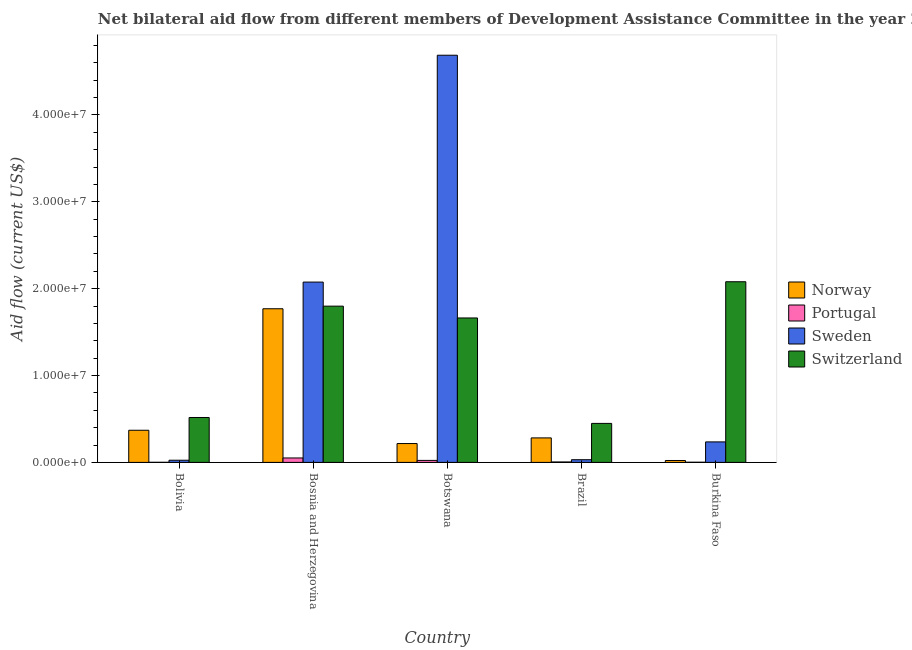Are the number of bars per tick equal to the number of legend labels?
Offer a terse response. Yes. How many bars are there on the 1st tick from the right?
Ensure brevity in your answer.  4. In how many cases, is the number of bars for a given country not equal to the number of legend labels?
Ensure brevity in your answer.  0. What is the amount of aid given by norway in Bolivia?
Your answer should be very brief. 3.70e+06. Across all countries, what is the maximum amount of aid given by norway?
Your answer should be compact. 1.77e+07. Across all countries, what is the minimum amount of aid given by portugal?
Provide a short and direct response. 10000. In which country was the amount of aid given by switzerland maximum?
Make the answer very short. Burkina Faso. What is the total amount of aid given by switzerland in the graph?
Offer a terse response. 6.51e+07. What is the difference between the amount of aid given by norway in Brazil and that in Burkina Faso?
Give a very brief answer. 2.60e+06. What is the difference between the amount of aid given by norway in Bolivia and the amount of aid given by portugal in Brazil?
Your response must be concise. 3.65e+06. What is the average amount of aid given by norway per country?
Your response must be concise. 5.32e+06. What is the difference between the amount of aid given by sweden and amount of aid given by portugal in Bolivia?
Your answer should be very brief. 2.40e+05. What is the ratio of the amount of aid given by switzerland in Bosnia and Herzegovina to that in Burkina Faso?
Your answer should be compact. 0.86. Is the amount of aid given by norway in Brazil less than that in Burkina Faso?
Ensure brevity in your answer.  No. What is the difference between the highest and the second highest amount of aid given by sweden?
Provide a succinct answer. 2.61e+07. What is the difference between the highest and the lowest amount of aid given by norway?
Provide a short and direct response. 1.75e+07. In how many countries, is the amount of aid given by sweden greater than the average amount of aid given by sweden taken over all countries?
Provide a succinct answer. 2. Is it the case that in every country, the sum of the amount of aid given by portugal and amount of aid given by sweden is greater than the sum of amount of aid given by switzerland and amount of aid given by norway?
Provide a succinct answer. No. What does the 3rd bar from the left in Bolivia represents?
Your answer should be compact. Sweden. What does the 1st bar from the right in Botswana represents?
Offer a very short reply. Switzerland. How many countries are there in the graph?
Your response must be concise. 5. Are the values on the major ticks of Y-axis written in scientific E-notation?
Offer a very short reply. Yes. Does the graph contain grids?
Make the answer very short. No. Where does the legend appear in the graph?
Give a very brief answer. Center right. How many legend labels are there?
Provide a succinct answer. 4. How are the legend labels stacked?
Your answer should be very brief. Vertical. What is the title of the graph?
Give a very brief answer. Net bilateral aid flow from different members of Development Assistance Committee in the year 2005. Does "CO2 damage" appear as one of the legend labels in the graph?
Offer a terse response. No. What is the label or title of the X-axis?
Provide a short and direct response. Country. What is the Aid flow (current US$) of Norway in Bolivia?
Make the answer very short. 3.70e+06. What is the Aid flow (current US$) of Sweden in Bolivia?
Ensure brevity in your answer.  2.50e+05. What is the Aid flow (current US$) in Switzerland in Bolivia?
Your answer should be compact. 5.17e+06. What is the Aid flow (current US$) of Norway in Bosnia and Herzegovina?
Make the answer very short. 1.77e+07. What is the Aid flow (current US$) of Portugal in Bosnia and Herzegovina?
Offer a very short reply. 5.10e+05. What is the Aid flow (current US$) in Sweden in Bosnia and Herzegovina?
Your answer should be very brief. 2.08e+07. What is the Aid flow (current US$) in Switzerland in Bosnia and Herzegovina?
Your answer should be very brief. 1.80e+07. What is the Aid flow (current US$) of Norway in Botswana?
Your answer should be compact. 2.17e+06. What is the Aid flow (current US$) of Sweden in Botswana?
Your answer should be compact. 4.69e+07. What is the Aid flow (current US$) of Switzerland in Botswana?
Keep it short and to the point. 1.66e+07. What is the Aid flow (current US$) in Norway in Brazil?
Ensure brevity in your answer.  2.82e+06. What is the Aid flow (current US$) in Portugal in Brazil?
Offer a terse response. 5.00e+04. What is the Aid flow (current US$) of Switzerland in Brazil?
Offer a very short reply. 4.49e+06. What is the Aid flow (current US$) in Sweden in Burkina Faso?
Your answer should be very brief. 2.36e+06. What is the Aid flow (current US$) in Switzerland in Burkina Faso?
Your answer should be very brief. 2.08e+07. Across all countries, what is the maximum Aid flow (current US$) of Norway?
Your answer should be compact. 1.77e+07. Across all countries, what is the maximum Aid flow (current US$) of Portugal?
Provide a short and direct response. 5.10e+05. Across all countries, what is the maximum Aid flow (current US$) in Sweden?
Your answer should be compact. 4.69e+07. Across all countries, what is the maximum Aid flow (current US$) in Switzerland?
Offer a terse response. 2.08e+07. Across all countries, what is the minimum Aid flow (current US$) in Switzerland?
Provide a succinct answer. 4.49e+06. What is the total Aid flow (current US$) of Norway in the graph?
Make the answer very short. 2.66e+07. What is the total Aid flow (current US$) of Portugal in the graph?
Offer a very short reply. 8.20e+05. What is the total Aid flow (current US$) in Sweden in the graph?
Ensure brevity in your answer.  7.06e+07. What is the total Aid flow (current US$) of Switzerland in the graph?
Offer a very short reply. 6.51e+07. What is the difference between the Aid flow (current US$) in Norway in Bolivia and that in Bosnia and Herzegovina?
Your answer should be compact. -1.40e+07. What is the difference between the Aid flow (current US$) of Portugal in Bolivia and that in Bosnia and Herzegovina?
Offer a terse response. -5.00e+05. What is the difference between the Aid flow (current US$) in Sweden in Bolivia and that in Bosnia and Herzegovina?
Give a very brief answer. -2.05e+07. What is the difference between the Aid flow (current US$) in Switzerland in Bolivia and that in Bosnia and Herzegovina?
Offer a very short reply. -1.28e+07. What is the difference between the Aid flow (current US$) of Norway in Bolivia and that in Botswana?
Your answer should be compact. 1.53e+06. What is the difference between the Aid flow (current US$) in Portugal in Bolivia and that in Botswana?
Make the answer very short. -2.20e+05. What is the difference between the Aid flow (current US$) of Sweden in Bolivia and that in Botswana?
Offer a very short reply. -4.66e+07. What is the difference between the Aid flow (current US$) in Switzerland in Bolivia and that in Botswana?
Provide a short and direct response. -1.15e+07. What is the difference between the Aid flow (current US$) of Norway in Bolivia and that in Brazil?
Offer a terse response. 8.80e+05. What is the difference between the Aid flow (current US$) in Portugal in Bolivia and that in Brazil?
Your answer should be very brief. -4.00e+04. What is the difference between the Aid flow (current US$) in Sweden in Bolivia and that in Brazil?
Your answer should be compact. -6.00e+04. What is the difference between the Aid flow (current US$) in Switzerland in Bolivia and that in Brazil?
Your answer should be very brief. 6.80e+05. What is the difference between the Aid flow (current US$) of Norway in Bolivia and that in Burkina Faso?
Offer a terse response. 3.48e+06. What is the difference between the Aid flow (current US$) of Portugal in Bolivia and that in Burkina Faso?
Your answer should be very brief. -10000. What is the difference between the Aid flow (current US$) of Sweden in Bolivia and that in Burkina Faso?
Give a very brief answer. -2.11e+06. What is the difference between the Aid flow (current US$) of Switzerland in Bolivia and that in Burkina Faso?
Your response must be concise. -1.56e+07. What is the difference between the Aid flow (current US$) of Norway in Bosnia and Herzegovina and that in Botswana?
Your answer should be compact. 1.55e+07. What is the difference between the Aid flow (current US$) in Portugal in Bosnia and Herzegovina and that in Botswana?
Provide a short and direct response. 2.80e+05. What is the difference between the Aid flow (current US$) in Sweden in Bosnia and Herzegovina and that in Botswana?
Your answer should be compact. -2.61e+07. What is the difference between the Aid flow (current US$) of Switzerland in Bosnia and Herzegovina and that in Botswana?
Keep it short and to the point. 1.36e+06. What is the difference between the Aid flow (current US$) of Norway in Bosnia and Herzegovina and that in Brazil?
Keep it short and to the point. 1.49e+07. What is the difference between the Aid flow (current US$) in Portugal in Bosnia and Herzegovina and that in Brazil?
Give a very brief answer. 4.60e+05. What is the difference between the Aid flow (current US$) in Sweden in Bosnia and Herzegovina and that in Brazil?
Keep it short and to the point. 2.04e+07. What is the difference between the Aid flow (current US$) of Switzerland in Bosnia and Herzegovina and that in Brazil?
Offer a terse response. 1.35e+07. What is the difference between the Aid flow (current US$) of Norway in Bosnia and Herzegovina and that in Burkina Faso?
Your response must be concise. 1.75e+07. What is the difference between the Aid flow (current US$) in Portugal in Bosnia and Herzegovina and that in Burkina Faso?
Offer a very short reply. 4.90e+05. What is the difference between the Aid flow (current US$) of Sweden in Bosnia and Herzegovina and that in Burkina Faso?
Your response must be concise. 1.84e+07. What is the difference between the Aid flow (current US$) of Switzerland in Bosnia and Herzegovina and that in Burkina Faso?
Give a very brief answer. -2.81e+06. What is the difference between the Aid flow (current US$) in Norway in Botswana and that in Brazil?
Ensure brevity in your answer.  -6.50e+05. What is the difference between the Aid flow (current US$) of Sweden in Botswana and that in Brazil?
Your response must be concise. 4.66e+07. What is the difference between the Aid flow (current US$) in Switzerland in Botswana and that in Brazil?
Give a very brief answer. 1.21e+07. What is the difference between the Aid flow (current US$) of Norway in Botswana and that in Burkina Faso?
Ensure brevity in your answer.  1.95e+06. What is the difference between the Aid flow (current US$) in Sweden in Botswana and that in Burkina Faso?
Make the answer very short. 4.45e+07. What is the difference between the Aid flow (current US$) of Switzerland in Botswana and that in Burkina Faso?
Offer a terse response. -4.17e+06. What is the difference between the Aid flow (current US$) of Norway in Brazil and that in Burkina Faso?
Provide a succinct answer. 2.60e+06. What is the difference between the Aid flow (current US$) of Portugal in Brazil and that in Burkina Faso?
Keep it short and to the point. 3.00e+04. What is the difference between the Aid flow (current US$) in Sweden in Brazil and that in Burkina Faso?
Give a very brief answer. -2.05e+06. What is the difference between the Aid flow (current US$) of Switzerland in Brazil and that in Burkina Faso?
Your response must be concise. -1.63e+07. What is the difference between the Aid flow (current US$) in Norway in Bolivia and the Aid flow (current US$) in Portugal in Bosnia and Herzegovina?
Provide a short and direct response. 3.19e+06. What is the difference between the Aid flow (current US$) of Norway in Bolivia and the Aid flow (current US$) of Sweden in Bosnia and Herzegovina?
Give a very brief answer. -1.71e+07. What is the difference between the Aid flow (current US$) in Norway in Bolivia and the Aid flow (current US$) in Switzerland in Bosnia and Herzegovina?
Your response must be concise. -1.43e+07. What is the difference between the Aid flow (current US$) in Portugal in Bolivia and the Aid flow (current US$) in Sweden in Bosnia and Herzegovina?
Make the answer very short. -2.08e+07. What is the difference between the Aid flow (current US$) of Portugal in Bolivia and the Aid flow (current US$) of Switzerland in Bosnia and Herzegovina?
Offer a terse response. -1.80e+07. What is the difference between the Aid flow (current US$) in Sweden in Bolivia and the Aid flow (current US$) in Switzerland in Bosnia and Herzegovina?
Offer a very short reply. -1.77e+07. What is the difference between the Aid flow (current US$) of Norway in Bolivia and the Aid flow (current US$) of Portugal in Botswana?
Make the answer very short. 3.47e+06. What is the difference between the Aid flow (current US$) in Norway in Bolivia and the Aid flow (current US$) in Sweden in Botswana?
Your response must be concise. -4.32e+07. What is the difference between the Aid flow (current US$) of Norway in Bolivia and the Aid flow (current US$) of Switzerland in Botswana?
Ensure brevity in your answer.  -1.29e+07. What is the difference between the Aid flow (current US$) in Portugal in Bolivia and the Aid flow (current US$) in Sweden in Botswana?
Give a very brief answer. -4.69e+07. What is the difference between the Aid flow (current US$) in Portugal in Bolivia and the Aid flow (current US$) in Switzerland in Botswana?
Offer a terse response. -1.66e+07. What is the difference between the Aid flow (current US$) of Sweden in Bolivia and the Aid flow (current US$) of Switzerland in Botswana?
Provide a short and direct response. -1.64e+07. What is the difference between the Aid flow (current US$) in Norway in Bolivia and the Aid flow (current US$) in Portugal in Brazil?
Offer a terse response. 3.65e+06. What is the difference between the Aid flow (current US$) in Norway in Bolivia and the Aid flow (current US$) in Sweden in Brazil?
Provide a short and direct response. 3.39e+06. What is the difference between the Aid flow (current US$) in Norway in Bolivia and the Aid flow (current US$) in Switzerland in Brazil?
Provide a short and direct response. -7.90e+05. What is the difference between the Aid flow (current US$) of Portugal in Bolivia and the Aid flow (current US$) of Sweden in Brazil?
Offer a terse response. -3.00e+05. What is the difference between the Aid flow (current US$) in Portugal in Bolivia and the Aid flow (current US$) in Switzerland in Brazil?
Give a very brief answer. -4.48e+06. What is the difference between the Aid flow (current US$) of Sweden in Bolivia and the Aid flow (current US$) of Switzerland in Brazil?
Ensure brevity in your answer.  -4.24e+06. What is the difference between the Aid flow (current US$) of Norway in Bolivia and the Aid flow (current US$) of Portugal in Burkina Faso?
Ensure brevity in your answer.  3.68e+06. What is the difference between the Aid flow (current US$) of Norway in Bolivia and the Aid flow (current US$) of Sweden in Burkina Faso?
Ensure brevity in your answer.  1.34e+06. What is the difference between the Aid flow (current US$) of Norway in Bolivia and the Aid flow (current US$) of Switzerland in Burkina Faso?
Offer a terse response. -1.71e+07. What is the difference between the Aid flow (current US$) in Portugal in Bolivia and the Aid flow (current US$) in Sweden in Burkina Faso?
Provide a succinct answer. -2.35e+06. What is the difference between the Aid flow (current US$) in Portugal in Bolivia and the Aid flow (current US$) in Switzerland in Burkina Faso?
Provide a short and direct response. -2.08e+07. What is the difference between the Aid flow (current US$) of Sweden in Bolivia and the Aid flow (current US$) of Switzerland in Burkina Faso?
Offer a very short reply. -2.06e+07. What is the difference between the Aid flow (current US$) in Norway in Bosnia and Herzegovina and the Aid flow (current US$) in Portugal in Botswana?
Offer a terse response. 1.75e+07. What is the difference between the Aid flow (current US$) in Norway in Bosnia and Herzegovina and the Aid flow (current US$) in Sweden in Botswana?
Offer a terse response. -2.92e+07. What is the difference between the Aid flow (current US$) of Norway in Bosnia and Herzegovina and the Aid flow (current US$) of Switzerland in Botswana?
Your answer should be compact. 1.06e+06. What is the difference between the Aid flow (current US$) of Portugal in Bosnia and Herzegovina and the Aid flow (current US$) of Sweden in Botswana?
Ensure brevity in your answer.  -4.64e+07. What is the difference between the Aid flow (current US$) in Portugal in Bosnia and Herzegovina and the Aid flow (current US$) in Switzerland in Botswana?
Give a very brief answer. -1.61e+07. What is the difference between the Aid flow (current US$) in Sweden in Bosnia and Herzegovina and the Aid flow (current US$) in Switzerland in Botswana?
Provide a short and direct response. 4.13e+06. What is the difference between the Aid flow (current US$) in Norway in Bosnia and Herzegovina and the Aid flow (current US$) in Portugal in Brazil?
Offer a terse response. 1.76e+07. What is the difference between the Aid flow (current US$) in Norway in Bosnia and Herzegovina and the Aid flow (current US$) in Sweden in Brazil?
Your answer should be very brief. 1.74e+07. What is the difference between the Aid flow (current US$) in Norway in Bosnia and Herzegovina and the Aid flow (current US$) in Switzerland in Brazil?
Offer a very short reply. 1.32e+07. What is the difference between the Aid flow (current US$) in Portugal in Bosnia and Herzegovina and the Aid flow (current US$) in Switzerland in Brazil?
Provide a short and direct response. -3.98e+06. What is the difference between the Aid flow (current US$) of Sweden in Bosnia and Herzegovina and the Aid flow (current US$) of Switzerland in Brazil?
Your response must be concise. 1.63e+07. What is the difference between the Aid flow (current US$) in Norway in Bosnia and Herzegovina and the Aid flow (current US$) in Portugal in Burkina Faso?
Offer a very short reply. 1.77e+07. What is the difference between the Aid flow (current US$) of Norway in Bosnia and Herzegovina and the Aid flow (current US$) of Sweden in Burkina Faso?
Offer a very short reply. 1.53e+07. What is the difference between the Aid flow (current US$) of Norway in Bosnia and Herzegovina and the Aid flow (current US$) of Switzerland in Burkina Faso?
Ensure brevity in your answer.  -3.11e+06. What is the difference between the Aid flow (current US$) in Portugal in Bosnia and Herzegovina and the Aid flow (current US$) in Sweden in Burkina Faso?
Keep it short and to the point. -1.85e+06. What is the difference between the Aid flow (current US$) of Portugal in Bosnia and Herzegovina and the Aid flow (current US$) of Switzerland in Burkina Faso?
Offer a terse response. -2.03e+07. What is the difference between the Aid flow (current US$) in Sweden in Bosnia and Herzegovina and the Aid flow (current US$) in Switzerland in Burkina Faso?
Your answer should be very brief. -4.00e+04. What is the difference between the Aid flow (current US$) of Norway in Botswana and the Aid flow (current US$) of Portugal in Brazil?
Ensure brevity in your answer.  2.12e+06. What is the difference between the Aid flow (current US$) of Norway in Botswana and the Aid flow (current US$) of Sweden in Brazil?
Provide a short and direct response. 1.86e+06. What is the difference between the Aid flow (current US$) of Norway in Botswana and the Aid flow (current US$) of Switzerland in Brazil?
Offer a terse response. -2.32e+06. What is the difference between the Aid flow (current US$) of Portugal in Botswana and the Aid flow (current US$) of Sweden in Brazil?
Your answer should be very brief. -8.00e+04. What is the difference between the Aid flow (current US$) in Portugal in Botswana and the Aid flow (current US$) in Switzerland in Brazil?
Ensure brevity in your answer.  -4.26e+06. What is the difference between the Aid flow (current US$) of Sweden in Botswana and the Aid flow (current US$) of Switzerland in Brazil?
Offer a very short reply. 4.24e+07. What is the difference between the Aid flow (current US$) in Norway in Botswana and the Aid flow (current US$) in Portugal in Burkina Faso?
Your answer should be compact. 2.15e+06. What is the difference between the Aid flow (current US$) in Norway in Botswana and the Aid flow (current US$) in Sweden in Burkina Faso?
Your answer should be very brief. -1.90e+05. What is the difference between the Aid flow (current US$) of Norway in Botswana and the Aid flow (current US$) of Switzerland in Burkina Faso?
Make the answer very short. -1.86e+07. What is the difference between the Aid flow (current US$) of Portugal in Botswana and the Aid flow (current US$) of Sweden in Burkina Faso?
Make the answer very short. -2.13e+06. What is the difference between the Aid flow (current US$) in Portugal in Botswana and the Aid flow (current US$) in Switzerland in Burkina Faso?
Offer a terse response. -2.06e+07. What is the difference between the Aid flow (current US$) in Sweden in Botswana and the Aid flow (current US$) in Switzerland in Burkina Faso?
Keep it short and to the point. 2.61e+07. What is the difference between the Aid flow (current US$) of Norway in Brazil and the Aid flow (current US$) of Portugal in Burkina Faso?
Your answer should be very brief. 2.80e+06. What is the difference between the Aid flow (current US$) in Norway in Brazil and the Aid flow (current US$) in Sweden in Burkina Faso?
Your response must be concise. 4.60e+05. What is the difference between the Aid flow (current US$) of Norway in Brazil and the Aid flow (current US$) of Switzerland in Burkina Faso?
Offer a very short reply. -1.80e+07. What is the difference between the Aid flow (current US$) of Portugal in Brazil and the Aid flow (current US$) of Sweden in Burkina Faso?
Keep it short and to the point. -2.31e+06. What is the difference between the Aid flow (current US$) in Portugal in Brazil and the Aid flow (current US$) in Switzerland in Burkina Faso?
Your response must be concise. -2.08e+07. What is the difference between the Aid flow (current US$) in Sweden in Brazil and the Aid flow (current US$) in Switzerland in Burkina Faso?
Your response must be concise. -2.05e+07. What is the average Aid flow (current US$) of Norway per country?
Provide a succinct answer. 5.32e+06. What is the average Aid flow (current US$) of Portugal per country?
Your answer should be very brief. 1.64e+05. What is the average Aid flow (current US$) in Sweden per country?
Make the answer very short. 1.41e+07. What is the average Aid flow (current US$) in Switzerland per country?
Provide a succinct answer. 1.30e+07. What is the difference between the Aid flow (current US$) in Norway and Aid flow (current US$) in Portugal in Bolivia?
Offer a very short reply. 3.69e+06. What is the difference between the Aid flow (current US$) in Norway and Aid flow (current US$) in Sweden in Bolivia?
Provide a short and direct response. 3.45e+06. What is the difference between the Aid flow (current US$) of Norway and Aid flow (current US$) of Switzerland in Bolivia?
Offer a terse response. -1.47e+06. What is the difference between the Aid flow (current US$) in Portugal and Aid flow (current US$) in Sweden in Bolivia?
Your answer should be compact. -2.40e+05. What is the difference between the Aid flow (current US$) in Portugal and Aid flow (current US$) in Switzerland in Bolivia?
Make the answer very short. -5.16e+06. What is the difference between the Aid flow (current US$) of Sweden and Aid flow (current US$) of Switzerland in Bolivia?
Keep it short and to the point. -4.92e+06. What is the difference between the Aid flow (current US$) of Norway and Aid flow (current US$) of Portugal in Bosnia and Herzegovina?
Your answer should be very brief. 1.72e+07. What is the difference between the Aid flow (current US$) in Norway and Aid flow (current US$) in Sweden in Bosnia and Herzegovina?
Your answer should be compact. -3.07e+06. What is the difference between the Aid flow (current US$) of Norway and Aid flow (current US$) of Switzerland in Bosnia and Herzegovina?
Provide a short and direct response. -3.00e+05. What is the difference between the Aid flow (current US$) in Portugal and Aid flow (current US$) in Sweden in Bosnia and Herzegovina?
Offer a very short reply. -2.02e+07. What is the difference between the Aid flow (current US$) in Portugal and Aid flow (current US$) in Switzerland in Bosnia and Herzegovina?
Ensure brevity in your answer.  -1.75e+07. What is the difference between the Aid flow (current US$) of Sweden and Aid flow (current US$) of Switzerland in Bosnia and Herzegovina?
Offer a very short reply. 2.77e+06. What is the difference between the Aid flow (current US$) in Norway and Aid flow (current US$) in Portugal in Botswana?
Your answer should be very brief. 1.94e+06. What is the difference between the Aid flow (current US$) of Norway and Aid flow (current US$) of Sweden in Botswana?
Your response must be concise. -4.47e+07. What is the difference between the Aid flow (current US$) of Norway and Aid flow (current US$) of Switzerland in Botswana?
Give a very brief answer. -1.45e+07. What is the difference between the Aid flow (current US$) of Portugal and Aid flow (current US$) of Sweden in Botswana?
Provide a succinct answer. -4.66e+07. What is the difference between the Aid flow (current US$) of Portugal and Aid flow (current US$) of Switzerland in Botswana?
Offer a very short reply. -1.64e+07. What is the difference between the Aid flow (current US$) in Sweden and Aid flow (current US$) in Switzerland in Botswana?
Provide a short and direct response. 3.02e+07. What is the difference between the Aid flow (current US$) of Norway and Aid flow (current US$) of Portugal in Brazil?
Keep it short and to the point. 2.77e+06. What is the difference between the Aid flow (current US$) of Norway and Aid flow (current US$) of Sweden in Brazil?
Offer a very short reply. 2.51e+06. What is the difference between the Aid flow (current US$) of Norway and Aid flow (current US$) of Switzerland in Brazil?
Your answer should be compact. -1.67e+06. What is the difference between the Aid flow (current US$) of Portugal and Aid flow (current US$) of Sweden in Brazil?
Your response must be concise. -2.60e+05. What is the difference between the Aid flow (current US$) in Portugal and Aid flow (current US$) in Switzerland in Brazil?
Provide a succinct answer. -4.44e+06. What is the difference between the Aid flow (current US$) in Sweden and Aid flow (current US$) in Switzerland in Brazil?
Offer a very short reply. -4.18e+06. What is the difference between the Aid flow (current US$) of Norway and Aid flow (current US$) of Portugal in Burkina Faso?
Your answer should be very brief. 2.00e+05. What is the difference between the Aid flow (current US$) in Norway and Aid flow (current US$) in Sweden in Burkina Faso?
Your answer should be compact. -2.14e+06. What is the difference between the Aid flow (current US$) of Norway and Aid flow (current US$) of Switzerland in Burkina Faso?
Ensure brevity in your answer.  -2.06e+07. What is the difference between the Aid flow (current US$) in Portugal and Aid flow (current US$) in Sweden in Burkina Faso?
Provide a succinct answer. -2.34e+06. What is the difference between the Aid flow (current US$) of Portugal and Aid flow (current US$) of Switzerland in Burkina Faso?
Keep it short and to the point. -2.08e+07. What is the difference between the Aid flow (current US$) in Sweden and Aid flow (current US$) in Switzerland in Burkina Faso?
Your answer should be very brief. -1.84e+07. What is the ratio of the Aid flow (current US$) in Norway in Bolivia to that in Bosnia and Herzegovina?
Ensure brevity in your answer.  0.21. What is the ratio of the Aid flow (current US$) in Portugal in Bolivia to that in Bosnia and Herzegovina?
Make the answer very short. 0.02. What is the ratio of the Aid flow (current US$) in Sweden in Bolivia to that in Bosnia and Herzegovina?
Offer a terse response. 0.01. What is the ratio of the Aid flow (current US$) of Switzerland in Bolivia to that in Bosnia and Herzegovina?
Offer a terse response. 0.29. What is the ratio of the Aid flow (current US$) in Norway in Bolivia to that in Botswana?
Provide a succinct answer. 1.71. What is the ratio of the Aid flow (current US$) of Portugal in Bolivia to that in Botswana?
Give a very brief answer. 0.04. What is the ratio of the Aid flow (current US$) of Sweden in Bolivia to that in Botswana?
Offer a very short reply. 0.01. What is the ratio of the Aid flow (current US$) in Switzerland in Bolivia to that in Botswana?
Give a very brief answer. 0.31. What is the ratio of the Aid flow (current US$) of Norway in Bolivia to that in Brazil?
Make the answer very short. 1.31. What is the ratio of the Aid flow (current US$) of Sweden in Bolivia to that in Brazil?
Your answer should be very brief. 0.81. What is the ratio of the Aid flow (current US$) of Switzerland in Bolivia to that in Brazil?
Offer a very short reply. 1.15. What is the ratio of the Aid flow (current US$) of Norway in Bolivia to that in Burkina Faso?
Your answer should be very brief. 16.82. What is the ratio of the Aid flow (current US$) in Portugal in Bolivia to that in Burkina Faso?
Keep it short and to the point. 0.5. What is the ratio of the Aid flow (current US$) of Sweden in Bolivia to that in Burkina Faso?
Your answer should be very brief. 0.11. What is the ratio of the Aid flow (current US$) in Switzerland in Bolivia to that in Burkina Faso?
Provide a succinct answer. 0.25. What is the ratio of the Aid flow (current US$) in Norway in Bosnia and Herzegovina to that in Botswana?
Keep it short and to the point. 8.15. What is the ratio of the Aid flow (current US$) of Portugal in Bosnia and Herzegovina to that in Botswana?
Make the answer very short. 2.22. What is the ratio of the Aid flow (current US$) of Sweden in Bosnia and Herzegovina to that in Botswana?
Make the answer very short. 0.44. What is the ratio of the Aid flow (current US$) of Switzerland in Bosnia and Herzegovina to that in Botswana?
Provide a succinct answer. 1.08. What is the ratio of the Aid flow (current US$) of Norway in Bosnia and Herzegovina to that in Brazil?
Offer a terse response. 6.27. What is the ratio of the Aid flow (current US$) of Portugal in Bosnia and Herzegovina to that in Brazil?
Ensure brevity in your answer.  10.2. What is the ratio of the Aid flow (current US$) of Sweden in Bosnia and Herzegovina to that in Brazil?
Ensure brevity in your answer.  66.97. What is the ratio of the Aid flow (current US$) in Switzerland in Bosnia and Herzegovina to that in Brazil?
Provide a short and direct response. 4.01. What is the ratio of the Aid flow (current US$) in Norway in Bosnia and Herzegovina to that in Burkina Faso?
Ensure brevity in your answer.  80.41. What is the ratio of the Aid flow (current US$) of Portugal in Bosnia and Herzegovina to that in Burkina Faso?
Give a very brief answer. 25.5. What is the ratio of the Aid flow (current US$) of Sweden in Bosnia and Herzegovina to that in Burkina Faso?
Offer a very short reply. 8.8. What is the ratio of the Aid flow (current US$) in Switzerland in Bosnia and Herzegovina to that in Burkina Faso?
Offer a very short reply. 0.86. What is the ratio of the Aid flow (current US$) of Norway in Botswana to that in Brazil?
Keep it short and to the point. 0.77. What is the ratio of the Aid flow (current US$) of Sweden in Botswana to that in Brazil?
Your answer should be very brief. 151.23. What is the ratio of the Aid flow (current US$) of Switzerland in Botswana to that in Brazil?
Your response must be concise. 3.7. What is the ratio of the Aid flow (current US$) in Norway in Botswana to that in Burkina Faso?
Provide a short and direct response. 9.86. What is the ratio of the Aid flow (current US$) in Sweden in Botswana to that in Burkina Faso?
Offer a terse response. 19.86. What is the ratio of the Aid flow (current US$) of Switzerland in Botswana to that in Burkina Faso?
Your answer should be compact. 0.8. What is the ratio of the Aid flow (current US$) of Norway in Brazil to that in Burkina Faso?
Offer a very short reply. 12.82. What is the ratio of the Aid flow (current US$) in Portugal in Brazil to that in Burkina Faso?
Give a very brief answer. 2.5. What is the ratio of the Aid flow (current US$) of Sweden in Brazil to that in Burkina Faso?
Provide a succinct answer. 0.13. What is the ratio of the Aid flow (current US$) in Switzerland in Brazil to that in Burkina Faso?
Offer a very short reply. 0.22. What is the difference between the highest and the second highest Aid flow (current US$) of Norway?
Your response must be concise. 1.40e+07. What is the difference between the highest and the second highest Aid flow (current US$) of Sweden?
Provide a short and direct response. 2.61e+07. What is the difference between the highest and the second highest Aid flow (current US$) of Switzerland?
Offer a very short reply. 2.81e+06. What is the difference between the highest and the lowest Aid flow (current US$) of Norway?
Your answer should be very brief. 1.75e+07. What is the difference between the highest and the lowest Aid flow (current US$) in Portugal?
Make the answer very short. 5.00e+05. What is the difference between the highest and the lowest Aid flow (current US$) in Sweden?
Ensure brevity in your answer.  4.66e+07. What is the difference between the highest and the lowest Aid flow (current US$) of Switzerland?
Keep it short and to the point. 1.63e+07. 